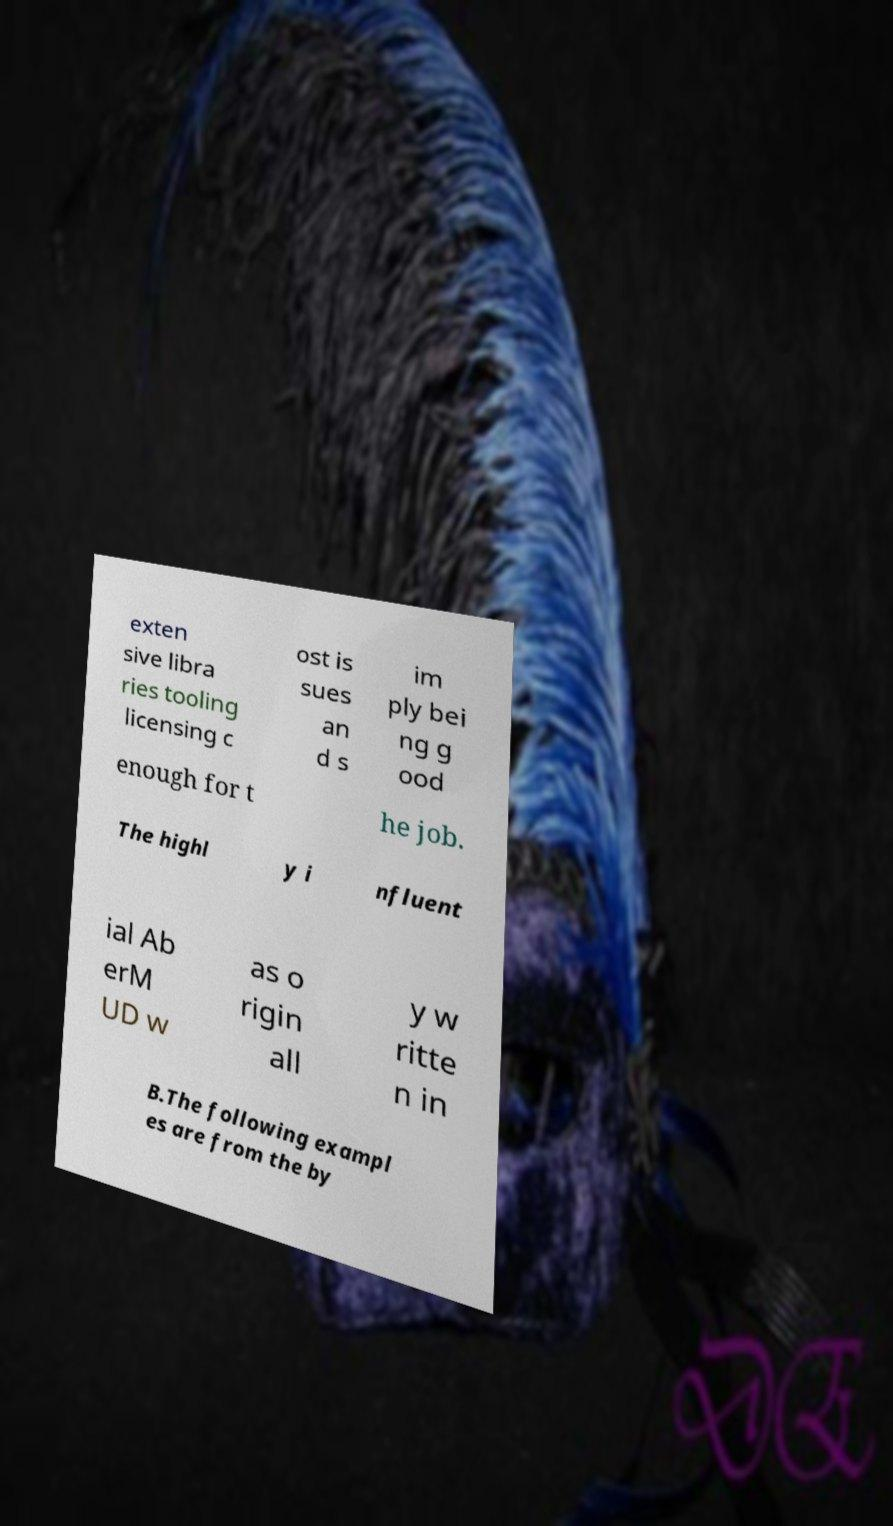Can you accurately transcribe the text from the provided image for me? exten sive libra ries tooling licensing c ost is sues an d s im ply bei ng g ood enough for t he job. The highl y i nfluent ial Ab erM UD w as o rigin all y w ritte n in B.The following exampl es are from the by 